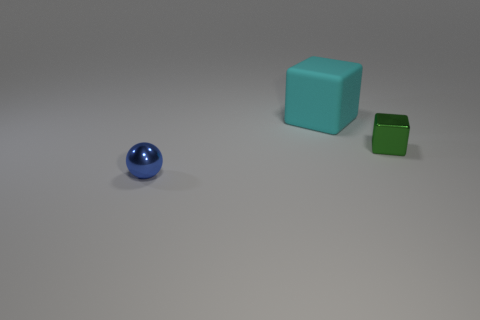Is there any other thing that has the same color as the tiny metallic ball?
Offer a terse response. No. Does the large thing have the same color as the small shiny object that is left of the tiny green thing?
Your response must be concise. No. Are there fewer tiny green things that are in front of the blue object than cyan rubber things?
Your answer should be compact. Yes. What is the material of the small thing that is behind the blue object?
Make the answer very short. Metal. How many other things are there of the same size as the rubber object?
Provide a succinct answer. 0. Does the matte cube have the same size as the ball on the left side of the tiny green metal cube?
Provide a short and direct response. No. There is a small thing on the right side of the block that is left of the shiny thing that is on the right side of the matte object; what is its shape?
Provide a short and direct response. Cube. Are there fewer big gray shiny spheres than tiny blue shiny spheres?
Your answer should be compact. Yes. There is a small green object; are there any shiny blocks on the right side of it?
Offer a very short reply. No. What is the shape of the object that is both in front of the big cyan object and left of the metal cube?
Provide a succinct answer. Sphere. 